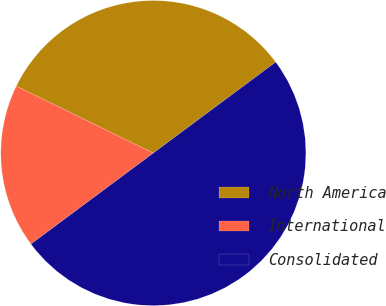Convert chart to OTSL. <chart><loc_0><loc_0><loc_500><loc_500><pie_chart><fcel>North America<fcel>International<fcel>Consolidated<nl><fcel>32.59%<fcel>17.41%<fcel>50.0%<nl></chart> 